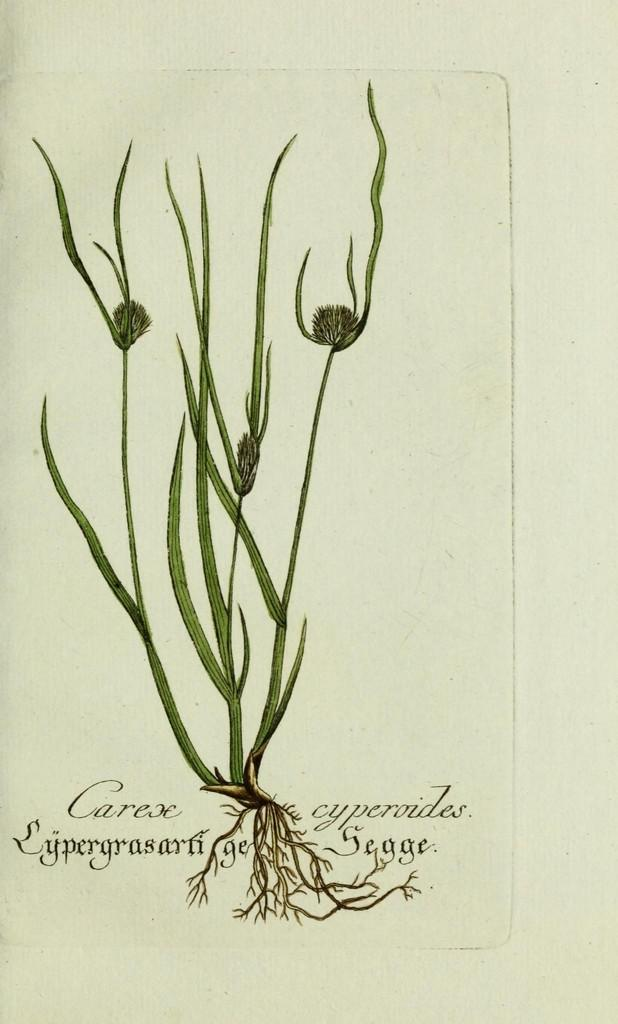What is the main subject of the drawing or textbook paper in the image? The main subject of the drawing or textbook paper is a plant. What other features can be seen in the drawing or textbook paper? There are roots depicted in the drawing or textbook paper, and there is text at the bottom of the drawing or textbook paper. Can you describe the rainstorm happening outside the structure in the image? There is no rainstorm or structure present in the image; it contains a drawing or textbook paper with a plant, roots, and text. 